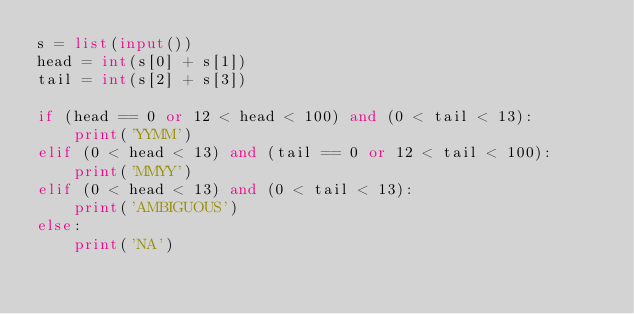Convert code to text. <code><loc_0><loc_0><loc_500><loc_500><_Python_>s = list(input())
head = int(s[0] + s[1])
tail = int(s[2] + s[3])

if (head == 0 or 12 < head < 100) and (0 < tail < 13):
    print('YYMM')
elif (0 < head < 13) and (tail == 0 or 12 < tail < 100):
    print('MMYY')
elif (0 < head < 13) and (0 < tail < 13):
    print('AMBIGUOUS')
else:
    print('NA')</code> 